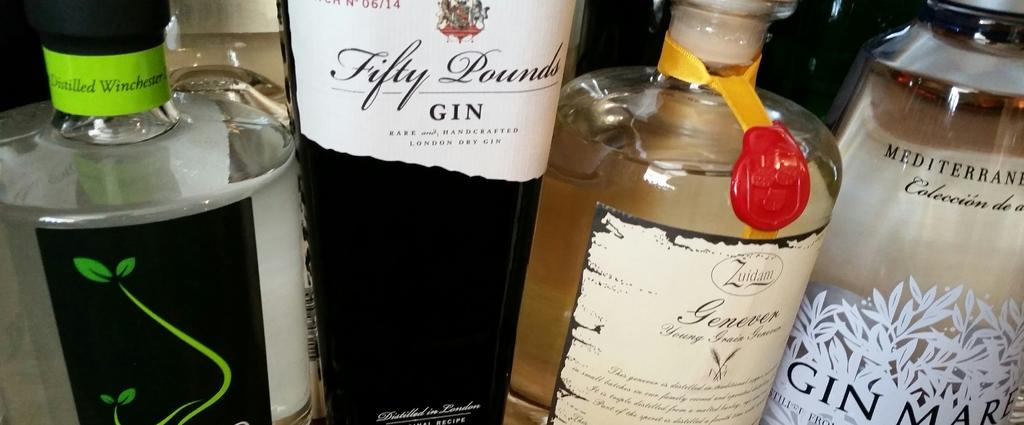<image>
Present a compact description of the photo's key features. the word gin is on one of the bottles 